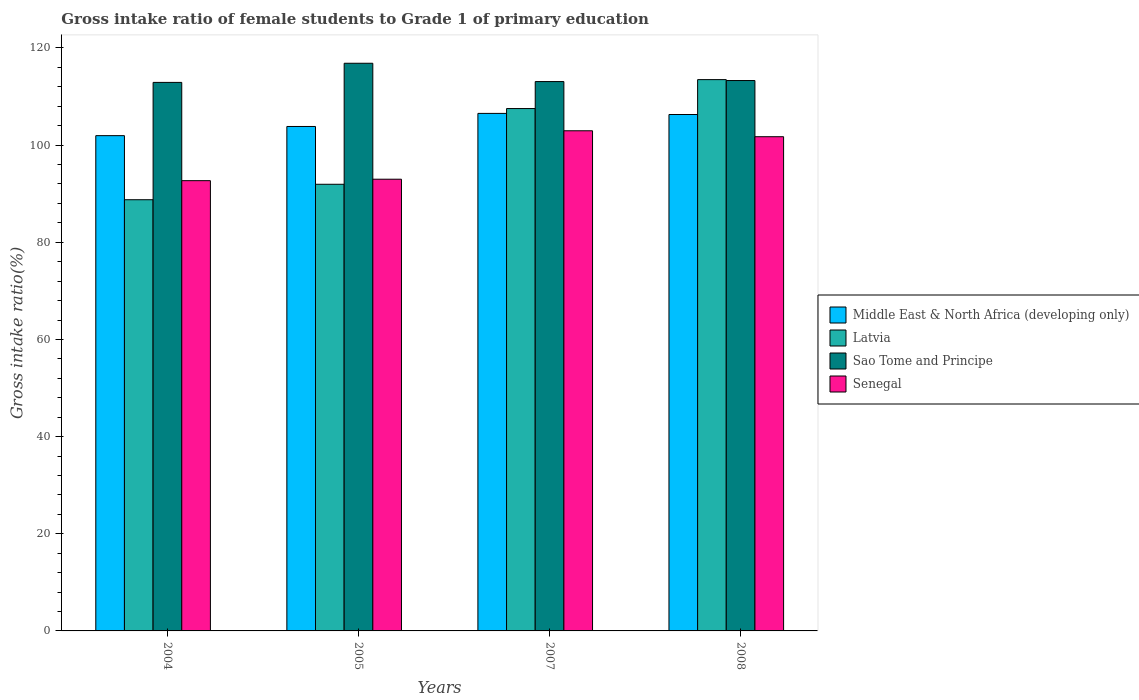How many different coloured bars are there?
Offer a terse response. 4. How many groups of bars are there?
Give a very brief answer. 4. Are the number of bars per tick equal to the number of legend labels?
Keep it short and to the point. Yes. How many bars are there on the 4th tick from the left?
Provide a succinct answer. 4. How many bars are there on the 2nd tick from the right?
Ensure brevity in your answer.  4. What is the gross intake ratio in Senegal in 2004?
Offer a terse response. 92.68. Across all years, what is the maximum gross intake ratio in Sao Tome and Principe?
Offer a terse response. 116.85. Across all years, what is the minimum gross intake ratio in Middle East & North Africa (developing only)?
Offer a terse response. 101.95. In which year was the gross intake ratio in Senegal maximum?
Your response must be concise. 2007. What is the total gross intake ratio in Sao Tome and Principe in the graph?
Your answer should be very brief. 456.13. What is the difference between the gross intake ratio in Senegal in 2004 and that in 2005?
Offer a very short reply. -0.3. What is the difference between the gross intake ratio in Latvia in 2007 and the gross intake ratio in Sao Tome and Principe in 2004?
Offer a terse response. -5.38. What is the average gross intake ratio in Sao Tome and Principe per year?
Provide a succinct answer. 114.03. In the year 2005, what is the difference between the gross intake ratio in Senegal and gross intake ratio in Middle East & North Africa (developing only)?
Make the answer very short. -10.86. In how many years, is the gross intake ratio in Senegal greater than 40 %?
Give a very brief answer. 4. What is the ratio of the gross intake ratio in Sao Tome and Principe in 2004 to that in 2008?
Provide a short and direct response. 1. Is the gross intake ratio in Sao Tome and Principe in 2005 less than that in 2008?
Keep it short and to the point. No. What is the difference between the highest and the second highest gross intake ratio in Sao Tome and Principe?
Provide a succinct answer. 3.56. What is the difference between the highest and the lowest gross intake ratio in Sao Tome and Principe?
Give a very brief answer. 3.94. In how many years, is the gross intake ratio in Senegal greater than the average gross intake ratio in Senegal taken over all years?
Your answer should be compact. 2. What does the 3rd bar from the left in 2007 represents?
Provide a short and direct response. Sao Tome and Principe. What does the 1st bar from the right in 2008 represents?
Your answer should be compact. Senegal. Is it the case that in every year, the sum of the gross intake ratio in Sao Tome and Principe and gross intake ratio in Middle East & North Africa (developing only) is greater than the gross intake ratio in Senegal?
Provide a short and direct response. Yes. How many bars are there?
Ensure brevity in your answer.  16. Does the graph contain any zero values?
Keep it short and to the point. No. How many legend labels are there?
Keep it short and to the point. 4. What is the title of the graph?
Keep it short and to the point. Gross intake ratio of female students to Grade 1 of primary education. What is the label or title of the Y-axis?
Your answer should be very brief. Gross intake ratio(%). What is the Gross intake ratio(%) of Middle East & North Africa (developing only) in 2004?
Your answer should be very brief. 101.95. What is the Gross intake ratio(%) of Latvia in 2004?
Your answer should be compact. 88.76. What is the Gross intake ratio(%) of Sao Tome and Principe in 2004?
Offer a very short reply. 112.91. What is the Gross intake ratio(%) in Senegal in 2004?
Provide a short and direct response. 92.68. What is the Gross intake ratio(%) in Middle East & North Africa (developing only) in 2005?
Offer a very short reply. 103.84. What is the Gross intake ratio(%) in Latvia in 2005?
Keep it short and to the point. 91.94. What is the Gross intake ratio(%) of Sao Tome and Principe in 2005?
Your response must be concise. 116.85. What is the Gross intake ratio(%) of Senegal in 2005?
Your response must be concise. 92.98. What is the Gross intake ratio(%) of Middle East & North Africa (developing only) in 2007?
Your response must be concise. 106.53. What is the Gross intake ratio(%) of Latvia in 2007?
Provide a succinct answer. 107.53. What is the Gross intake ratio(%) in Sao Tome and Principe in 2007?
Offer a terse response. 113.08. What is the Gross intake ratio(%) in Senegal in 2007?
Provide a succinct answer. 102.95. What is the Gross intake ratio(%) in Middle East & North Africa (developing only) in 2008?
Your answer should be compact. 106.3. What is the Gross intake ratio(%) in Latvia in 2008?
Make the answer very short. 113.48. What is the Gross intake ratio(%) of Sao Tome and Principe in 2008?
Provide a short and direct response. 113.29. What is the Gross intake ratio(%) in Senegal in 2008?
Keep it short and to the point. 101.73. Across all years, what is the maximum Gross intake ratio(%) of Middle East & North Africa (developing only)?
Give a very brief answer. 106.53. Across all years, what is the maximum Gross intake ratio(%) of Latvia?
Provide a short and direct response. 113.48. Across all years, what is the maximum Gross intake ratio(%) of Sao Tome and Principe?
Your answer should be compact. 116.85. Across all years, what is the maximum Gross intake ratio(%) of Senegal?
Provide a short and direct response. 102.95. Across all years, what is the minimum Gross intake ratio(%) of Middle East & North Africa (developing only)?
Give a very brief answer. 101.95. Across all years, what is the minimum Gross intake ratio(%) in Latvia?
Ensure brevity in your answer.  88.76. Across all years, what is the minimum Gross intake ratio(%) in Sao Tome and Principe?
Offer a terse response. 112.91. Across all years, what is the minimum Gross intake ratio(%) in Senegal?
Offer a terse response. 92.68. What is the total Gross intake ratio(%) of Middle East & North Africa (developing only) in the graph?
Ensure brevity in your answer.  418.62. What is the total Gross intake ratio(%) in Latvia in the graph?
Provide a succinct answer. 401.71. What is the total Gross intake ratio(%) in Sao Tome and Principe in the graph?
Provide a short and direct response. 456.13. What is the total Gross intake ratio(%) of Senegal in the graph?
Provide a short and direct response. 390.35. What is the difference between the Gross intake ratio(%) of Middle East & North Africa (developing only) in 2004 and that in 2005?
Ensure brevity in your answer.  -1.89. What is the difference between the Gross intake ratio(%) of Latvia in 2004 and that in 2005?
Provide a short and direct response. -3.18. What is the difference between the Gross intake ratio(%) in Sao Tome and Principe in 2004 and that in 2005?
Provide a succinct answer. -3.94. What is the difference between the Gross intake ratio(%) of Senegal in 2004 and that in 2005?
Offer a terse response. -0.3. What is the difference between the Gross intake ratio(%) of Middle East & North Africa (developing only) in 2004 and that in 2007?
Your response must be concise. -4.58. What is the difference between the Gross intake ratio(%) in Latvia in 2004 and that in 2007?
Give a very brief answer. -18.77. What is the difference between the Gross intake ratio(%) of Sao Tome and Principe in 2004 and that in 2007?
Give a very brief answer. -0.17. What is the difference between the Gross intake ratio(%) of Senegal in 2004 and that in 2007?
Ensure brevity in your answer.  -10.27. What is the difference between the Gross intake ratio(%) in Middle East & North Africa (developing only) in 2004 and that in 2008?
Offer a very short reply. -4.35. What is the difference between the Gross intake ratio(%) in Latvia in 2004 and that in 2008?
Provide a succinct answer. -24.72. What is the difference between the Gross intake ratio(%) of Sao Tome and Principe in 2004 and that in 2008?
Keep it short and to the point. -0.38. What is the difference between the Gross intake ratio(%) of Senegal in 2004 and that in 2008?
Your answer should be very brief. -9.05. What is the difference between the Gross intake ratio(%) in Middle East & North Africa (developing only) in 2005 and that in 2007?
Give a very brief answer. -2.69. What is the difference between the Gross intake ratio(%) in Latvia in 2005 and that in 2007?
Give a very brief answer. -15.59. What is the difference between the Gross intake ratio(%) in Sao Tome and Principe in 2005 and that in 2007?
Ensure brevity in your answer.  3.77. What is the difference between the Gross intake ratio(%) of Senegal in 2005 and that in 2007?
Offer a very short reply. -9.97. What is the difference between the Gross intake ratio(%) of Middle East & North Africa (developing only) in 2005 and that in 2008?
Your answer should be very brief. -2.46. What is the difference between the Gross intake ratio(%) of Latvia in 2005 and that in 2008?
Offer a terse response. -21.54. What is the difference between the Gross intake ratio(%) in Sao Tome and Principe in 2005 and that in 2008?
Provide a succinct answer. 3.56. What is the difference between the Gross intake ratio(%) of Senegal in 2005 and that in 2008?
Your answer should be very brief. -8.75. What is the difference between the Gross intake ratio(%) of Middle East & North Africa (developing only) in 2007 and that in 2008?
Keep it short and to the point. 0.23. What is the difference between the Gross intake ratio(%) of Latvia in 2007 and that in 2008?
Give a very brief answer. -5.96. What is the difference between the Gross intake ratio(%) in Sao Tome and Principe in 2007 and that in 2008?
Ensure brevity in your answer.  -0.21. What is the difference between the Gross intake ratio(%) in Senegal in 2007 and that in 2008?
Offer a terse response. 1.22. What is the difference between the Gross intake ratio(%) in Middle East & North Africa (developing only) in 2004 and the Gross intake ratio(%) in Latvia in 2005?
Make the answer very short. 10.01. What is the difference between the Gross intake ratio(%) of Middle East & North Africa (developing only) in 2004 and the Gross intake ratio(%) of Sao Tome and Principe in 2005?
Ensure brevity in your answer.  -14.9. What is the difference between the Gross intake ratio(%) of Middle East & North Africa (developing only) in 2004 and the Gross intake ratio(%) of Senegal in 2005?
Your answer should be very brief. 8.96. What is the difference between the Gross intake ratio(%) of Latvia in 2004 and the Gross intake ratio(%) of Sao Tome and Principe in 2005?
Give a very brief answer. -28.09. What is the difference between the Gross intake ratio(%) of Latvia in 2004 and the Gross intake ratio(%) of Senegal in 2005?
Your answer should be compact. -4.22. What is the difference between the Gross intake ratio(%) in Sao Tome and Principe in 2004 and the Gross intake ratio(%) in Senegal in 2005?
Offer a terse response. 19.93. What is the difference between the Gross intake ratio(%) of Middle East & North Africa (developing only) in 2004 and the Gross intake ratio(%) of Latvia in 2007?
Your answer should be very brief. -5.58. What is the difference between the Gross intake ratio(%) of Middle East & North Africa (developing only) in 2004 and the Gross intake ratio(%) of Sao Tome and Principe in 2007?
Give a very brief answer. -11.13. What is the difference between the Gross intake ratio(%) in Middle East & North Africa (developing only) in 2004 and the Gross intake ratio(%) in Senegal in 2007?
Make the answer very short. -1.01. What is the difference between the Gross intake ratio(%) of Latvia in 2004 and the Gross intake ratio(%) of Sao Tome and Principe in 2007?
Provide a short and direct response. -24.32. What is the difference between the Gross intake ratio(%) in Latvia in 2004 and the Gross intake ratio(%) in Senegal in 2007?
Provide a succinct answer. -14.19. What is the difference between the Gross intake ratio(%) in Sao Tome and Principe in 2004 and the Gross intake ratio(%) in Senegal in 2007?
Give a very brief answer. 9.96. What is the difference between the Gross intake ratio(%) of Middle East & North Africa (developing only) in 2004 and the Gross intake ratio(%) of Latvia in 2008?
Ensure brevity in your answer.  -11.54. What is the difference between the Gross intake ratio(%) in Middle East & North Africa (developing only) in 2004 and the Gross intake ratio(%) in Sao Tome and Principe in 2008?
Your answer should be compact. -11.35. What is the difference between the Gross intake ratio(%) of Middle East & North Africa (developing only) in 2004 and the Gross intake ratio(%) of Senegal in 2008?
Make the answer very short. 0.22. What is the difference between the Gross intake ratio(%) in Latvia in 2004 and the Gross intake ratio(%) in Sao Tome and Principe in 2008?
Offer a terse response. -24.53. What is the difference between the Gross intake ratio(%) of Latvia in 2004 and the Gross intake ratio(%) of Senegal in 2008?
Your response must be concise. -12.97. What is the difference between the Gross intake ratio(%) of Sao Tome and Principe in 2004 and the Gross intake ratio(%) of Senegal in 2008?
Your answer should be compact. 11.18. What is the difference between the Gross intake ratio(%) of Middle East & North Africa (developing only) in 2005 and the Gross intake ratio(%) of Latvia in 2007?
Your response must be concise. -3.69. What is the difference between the Gross intake ratio(%) in Middle East & North Africa (developing only) in 2005 and the Gross intake ratio(%) in Sao Tome and Principe in 2007?
Provide a succinct answer. -9.24. What is the difference between the Gross intake ratio(%) of Middle East & North Africa (developing only) in 2005 and the Gross intake ratio(%) of Senegal in 2007?
Make the answer very short. 0.88. What is the difference between the Gross intake ratio(%) of Latvia in 2005 and the Gross intake ratio(%) of Sao Tome and Principe in 2007?
Offer a very short reply. -21.14. What is the difference between the Gross intake ratio(%) of Latvia in 2005 and the Gross intake ratio(%) of Senegal in 2007?
Offer a very short reply. -11.01. What is the difference between the Gross intake ratio(%) of Sao Tome and Principe in 2005 and the Gross intake ratio(%) of Senegal in 2007?
Offer a terse response. 13.9. What is the difference between the Gross intake ratio(%) of Middle East & North Africa (developing only) in 2005 and the Gross intake ratio(%) of Latvia in 2008?
Your answer should be very brief. -9.65. What is the difference between the Gross intake ratio(%) of Middle East & North Africa (developing only) in 2005 and the Gross intake ratio(%) of Sao Tome and Principe in 2008?
Provide a succinct answer. -9.46. What is the difference between the Gross intake ratio(%) in Middle East & North Africa (developing only) in 2005 and the Gross intake ratio(%) in Senegal in 2008?
Provide a short and direct response. 2.11. What is the difference between the Gross intake ratio(%) in Latvia in 2005 and the Gross intake ratio(%) in Sao Tome and Principe in 2008?
Your answer should be compact. -21.35. What is the difference between the Gross intake ratio(%) of Latvia in 2005 and the Gross intake ratio(%) of Senegal in 2008?
Offer a very short reply. -9.79. What is the difference between the Gross intake ratio(%) in Sao Tome and Principe in 2005 and the Gross intake ratio(%) in Senegal in 2008?
Provide a succinct answer. 15.12. What is the difference between the Gross intake ratio(%) of Middle East & North Africa (developing only) in 2007 and the Gross intake ratio(%) of Latvia in 2008?
Your response must be concise. -6.96. What is the difference between the Gross intake ratio(%) of Middle East & North Africa (developing only) in 2007 and the Gross intake ratio(%) of Sao Tome and Principe in 2008?
Your answer should be compact. -6.76. What is the difference between the Gross intake ratio(%) in Middle East & North Africa (developing only) in 2007 and the Gross intake ratio(%) in Senegal in 2008?
Offer a very short reply. 4.8. What is the difference between the Gross intake ratio(%) in Latvia in 2007 and the Gross intake ratio(%) in Sao Tome and Principe in 2008?
Your response must be concise. -5.77. What is the difference between the Gross intake ratio(%) in Latvia in 2007 and the Gross intake ratio(%) in Senegal in 2008?
Ensure brevity in your answer.  5.8. What is the difference between the Gross intake ratio(%) in Sao Tome and Principe in 2007 and the Gross intake ratio(%) in Senegal in 2008?
Your answer should be very brief. 11.35. What is the average Gross intake ratio(%) of Middle East & North Africa (developing only) per year?
Make the answer very short. 104.65. What is the average Gross intake ratio(%) of Latvia per year?
Keep it short and to the point. 100.43. What is the average Gross intake ratio(%) in Sao Tome and Principe per year?
Make the answer very short. 114.03. What is the average Gross intake ratio(%) in Senegal per year?
Your answer should be very brief. 97.59. In the year 2004, what is the difference between the Gross intake ratio(%) of Middle East & North Africa (developing only) and Gross intake ratio(%) of Latvia?
Make the answer very short. 13.19. In the year 2004, what is the difference between the Gross intake ratio(%) in Middle East & North Africa (developing only) and Gross intake ratio(%) in Sao Tome and Principe?
Ensure brevity in your answer.  -10.96. In the year 2004, what is the difference between the Gross intake ratio(%) in Middle East & North Africa (developing only) and Gross intake ratio(%) in Senegal?
Give a very brief answer. 9.26. In the year 2004, what is the difference between the Gross intake ratio(%) of Latvia and Gross intake ratio(%) of Sao Tome and Principe?
Your answer should be very brief. -24.15. In the year 2004, what is the difference between the Gross intake ratio(%) of Latvia and Gross intake ratio(%) of Senegal?
Offer a terse response. -3.92. In the year 2004, what is the difference between the Gross intake ratio(%) in Sao Tome and Principe and Gross intake ratio(%) in Senegal?
Offer a very short reply. 20.23. In the year 2005, what is the difference between the Gross intake ratio(%) of Middle East & North Africa (developing only) and Gross intake ratio(%) of Latvia?
Keep it short and to the point. 11.9. In the year 2005, what is the difference between the Gross intake ratio(%) in Middle East & North Africa (developing only) and Gross intake ratio(%) in Sao Tome and Principe?
Offer a very short reply. -13.01. In the year 2005, what is the difference between the Gross intake ratio(%) of Middle East & North Africa (developing only) and Gross intake ratio(%) of Senegal?
Offer a very short reply. 10.86. In the year 2005, what is the difference between the Gross intake ratio(%) of Latvia and Gross intake ratio(%) of Sao Tome and Principe?
Keep it short and to the point. -24.91. In the year 2005, what is the difference between the Gross intake ratio(%) in Latvia and Gross intake ratio(%) in Senegal?
Make the answer very short. -1.04. In the year 2005, what is the difference between the Gross intake ratio(%) in Sao Tome and Principe and Gross intake ratio(%) in Senegal?
Provide a succinct answer. 23.87. In the year 2007, what is the difference between the Gross intake ratio(%) in Middle East & North Africa (developing only) and Gross intake ratio(%) in Latvia?
Keep it short and to the point. -1. In the year 2007, what is the difference between the Gross intake ratio(%) in Middle East & North Africa (developing only) and Gross intake ratio(%) in Sao Tome and Principe?
Give a very brief answer. -6.55. In the year 2007, what is the difference between the Gross intake ratio(%) in Middle East & North Africa (developing only) and Gross intake ratio(%) in Senegal?
Provide a succinct answer. 3.58. In the year 2007, what is the difference between the Gross intake ratio(%) of Latvia and Gross intake ratio(%) of Sao Tome and Principe?
Provide a succinct answer. -5.55. In the year 2007, what is the difference between the Gross intake ratio(%) of Latvia and Gross intake ratio(%) of Senegal?
Your answer should be very brief. 4.57. In the year 2007, what is the difference between the Gross intake ratio(%) of Sao Tome and Principe and Gross intake ratio(%) of Senegal?
Offer a very short reply. 10.13. In the year 2008, what is the difference between the Gross intake ratio(%) of Middle East & North Africa (developing only) and Gross intake ratio(%) of Latvia?
Make the answer very short. -7.18. In the year 2008, what is the difference between the Gross intake ratio(%) in Middle East & North Africa (developing only) and Gross intake ratio(%) in Sao Tome and Principe?
Ensure brevity in your answer.  -6.99. In the year 2008, what is the difference between the Gross intake ratio(%) of Middle East & North Africa (developing only) and Gross intake ratio(%) of Senegal?
Give a very brief answer. 4.57. In the year 2008, what is the difference between the Gross intake ratio(%) in Latvia and Gross intake ratio(%) in Sao Tome and Principe?
Keep it short and to the point. 0.19. In the year 2008, what is the difference between the Gross intake ratio(%) in Latvia and Gross intake ratio(%) in Senegal?
Make the answer very short. 11.76. In the year 2008, what is the difference between the Gross intake ratio(%) of Sao Tome and Principe and Gross intake ratio(%) of Senegal?
Offer a very short reply. 11.57. What is the ratio of the Gross intake ratio(%) of Middle East & North Africa (developing only) in 2004 to that in 2005?
Ensure brevity in your answer.  0.98. What is the ratio of the Gross intake ratio(%) of Latvia in 2004 to that in 2005?
Offer a terse response. 0.97. What is the ratio of the Gross intake ratio(%) in Sao Tome and Principe in 2004 to that in 2005?
Keep it short and to the point. 0.97. What is the ratio of the Gross intake ratio(%) of Middle East & North Africa (developing only) in 2004 to that in 2007?
Your answer should be compact. 0.96. What is the ratio of the Gross intake ratio(%) in Latvia in 2004 to that in 2007?
Your response must be concise. 0.83. What is the ratio of the Gross intake ratio(%) in Senegal in 2004 to that in 2007?
Your answer should be very brief. 0.9. What is the ratio of the Gross intake ratio(%) of Middle East & North Africa (developing only) in 2004 to that in 2008?
Offer a terse response. 0.96. What is the ratio of the Gross intake ratio(%) of Latvia in 2004 to that in 2008?
Ensure brevity in your answer.  0.78. What is the ratio of the Gross intake ratio(%) in Senegal in 2004 to that in 2008?
Your answer should be compact. 0.91. What is the ratio of the Gross intake ratio(%) in Middle East & North Africa (developing only) in 2005 to that in 2007?
Keep it short and to the point. 0.97. What is the ratio of the Gross intake ratio(%) in Latvia in 2005 to that in 2007?
Make the answer very short. 0.86. What is the ratio of the Gross intake ratio(%) of Senegal in 2005 to that in 2007?
Provide a succinct answer. 0.9. What is the ratio of the Gross intake ratio(%) in Middle East & North Africa (developing only) in 2005 to that in 2008?
Provide a succinct answer. 0.98. What is the ratio of the Gross intake ratio(%) of Latvia in 2005 to that in 2008?
Give a very brief answer. 0.81. What is the ratio of the Gross intake ratio(%) of Sao Tome and Principe in 2005 to that in 2008?
Your answer should be very brief. 1.03. What is the ratio of the Gross intake ratio(%) of Senegal in 2005 to that in 2008?
Provide a short and direct response. 0.91. What is the ratio of the Gross intake ratio(%) of Middle East & North Africa (developing only) in 2007 to that in 2008?
Offer a terse response. 1. What is the ratio of the Gross intake ratio(%) of Latvia in 2007 to that in 2008?
Your answer should be compact. 0.95. What is the ratio of the Gross intake ratio(%) in Sao Tome and Principe in 2007 to that in 2008?
Keep it short and to the point. 1. What is the difference between the highest and the second highest Gross intake ratio(%) of Middle East & North Africa (developing only)?
Keep it short and to the point. 0.23. What is the difference between the highest and the second highest Gross intake ratio(%) in Latvia?
Make the answer very short. 5.96. What is the difference between the highest and the second highest Gross intake ratio(%) in Sao Tome and Principe?
Give a very brief answer. 3.56. What is the difference between the highest and the second highest Gross intake ratio(%) of Senegal?
Give a very brief answer. 1.22. What is the difference between the highest and the lowest Gross intake ratio(%) in Middle East & North Africa (developing only)?
Your answer should be compact. 4.58. What is the difference between the highest and the lowest Gross intake ratio(%) in Latvia?
Offer a terse response. 24.72. What is the difference between the highest and the lowest Gross intake ratio(%) in Sao Tome and Principe?
Your answer should be very brief. 3.94. What is the difference between the highest and the lowest Gross intake ratio(%) in Senegal?
Your answer should be compact. 10.27. 